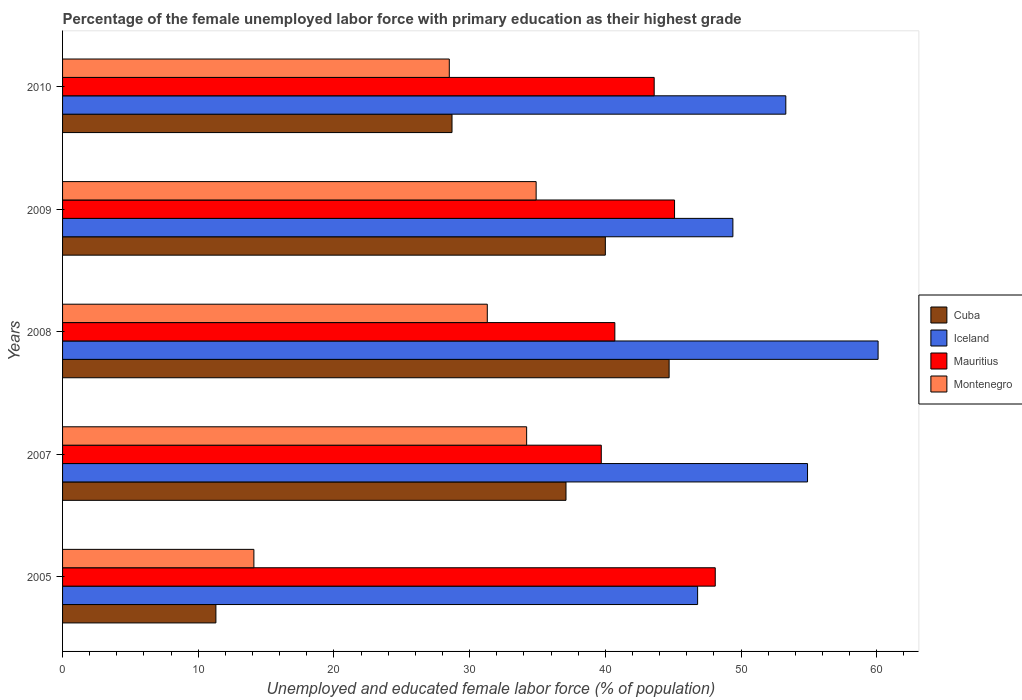How many different coloured bars are there?
Keep it short and to the point. 4. In how many cases, is the number of bars for a given year not equal to the number of legend labels?
Your answer should be compact. 0. What is the percentage of the unemployed female labor force with primary education in Cuba in 2007?
Offer a terse response. 37.1. Across all years, what is the maximum percentage of the unemployed female labor force with primary education in Iceland?
Offer a terse response. 60.1. Across all years, what is the minimum percentage of the unemployed female labor force with primary education in Montenegro?
Keep it short and to the point. 14.1. What is the total percentage of the unemployed female labor force with primary education in Iceland in the graph?
Provide a short and direct response. 264.5. What is the difference between the percentage of the unemployed female labor force with primary education in Cuba in 2008 and that in 2009?
Offer a very short reply. 4.7. What is the difference between the percentage of the unemployed female labor force with primary education in Iceland in 2008 and the percentage of the unemployed female labor force with primary education in Montenegro in 2007?
Give a very brief answer. 25.9. What is the average percentage of the unemployed female labor force with primary education in Montenegro per year?
Ensure brevity in your answer.  28.6. In the year 2010, what is the difference between the percentage of the unemployed female labor force with primary education in Montenegro and percentage of the unemployed female labor force with primary education in Cuba?
Provide a succinct answer. -0.2. In how many years, is the percentage of the unemployed female labor force with primary education in Cuba greater than 34 %?
Offer a terse response. 3. What is the ratio of the percentage of the unemployed female labor force with primary education in Iceland in 2008 to that in 2010?
Give a very brief answer. 1.13. Is the percentage of the unemployed female labor force with primary education in Montenegro in 2007 less than that in 2009?
Make the answer very short. Yes. What is the difference between the highest and the lowest percentage of the unemployed female labor force with primary education in Mauritius?
Give a very brief answer. 8.4. What does the 3rd bar from the bottom in 2009 represents?
Your answer should be compact. Mauritius. Are all the bars in the graph horizontal?
Give a very brief answer. Yes. How many years are there in the graph?
Offer a terse response. 5. What is the difference between two consecutive major ticks on the X-axis?
Make the answer very short. 10. Are the values on the major ticks of X-axis written in scientific E-notation?
Give a very brief answer. No. How many legend labels are there?
Your answer should be compact. 4. What is the title of the graph?
Your answer should be compact. Percentage of the female unemployed labor force with primary education as their highest grade. What is the label or title of the X-axis?
Your response must be concise. Unemployed and educated female labor force (% of population). What is the Unemployed and educated female labor force (% of population) of Cuba in 2005?
Your response must be concise. 11.3. What is the Unemployed and educated female labor force (% of population) in Iceland in 2005?
Provide a succinct answer. 46.8. What is the Unemployed and educated female labor force (% of population) in Mauritius in 2005?
Keep it short and to the point. 48.1. What is the Unemployed and educated female labor force (% of population) in Montenegro in 2005?
Make the answer very short. 14.1. What is the Unemployed and educated female labor force (% of population) in Cuba in 2007?
Make the answer very short. 37.1. What is the Unemployed and educated female labor force (% of population) in Iceland in 2007?
Offer a terse response. 54.9. What is the Unemployed and educated female labor force (% of population) in Mauritius in 2007?
Your response must be concise. 39.7. What is the Unemployed and educated female labor force (% of population) in Montenegro in 2007?
Provide a succinct answer. 34.2. What is the Unemployed and educated female labor force (% of population) in Cuba in 2008?
Provide a succinct answer. 44.7. What is the Unemployed and educated female labor force (% of population) of Iceland in 2008?
Your answer should be very brief. 60.1. What is the Unemployed and educated female labor force (% of population) of Mauritius in 2008?
Offer a very short reply. 40.7. What is the Unemployed and educated female labor force (% of population) in Montenegro in 2008?
Offer a terse response. 31.3. What is the Unemployed and educated female labor force (% of population) of Iceland in 2009?
Offer a very short reply. 49.4. What is the Unemployed and educated female labor force (% of population) of Mauritius in 2009?
Offer a terse response. 45.1. What is the Unemployed and educated female labor force (% of population) of Montenegro in 2009?
Offer a very short reply. 34.9. What is the Unemployed and educated female labor force (% of population) in Cuba in 2010?
Your answer should be very brief. 28.7. What is the Unemployed and educated female labor force (% of population) of Iceland in 2010?
Your answer should be compact. 53.3. What is the Unemployed and educated female labor force (% of population) in Mauritius in 2010?
Provide a short and direct response. 43.6. Across all years, what is the maximum Unemployed and educated female labor force (% of population) in Cuba?
Your answer should be very brief. 44.7. Across all years, what is the maximum Unemployed and educated female labor force (% of population) of Iceland?
Provide a short and direct response. 60.1. Across all years, what is the maximum Unemployed and educated female labor force (% of population) of Mauritius?
Make the answer very short. 48.1. Across all years, what is the maximum Unemployed and educated female labor force (% of population) in Montenegro?
Provide a succinct answer. 34.9. Across all years, what is the minimum Unemployed and educated female labor force (% of population) of Cuba?
Provide a short and direct response. 11.3. Across all years, what is the minimum Unemployed and educated female labor force (% of population) in Iceland?
Keep it short and to the point. 46.8. Across all years, what is the minimum Unemployed and educated female labor force (% of population) in Mauritius?
Offer a very short reply. 39.7. Across all years, what is the minimum Unemployed and educated female labor force (% of population) in Montenegro?
Offer a very short reply. 14.1. What is the total Unemployed and educated female labor force (% of population) of Cuba in the graph?
Your answer should be very brief. 161.8. What is the total Unemployed and educated female labor force (% of population) in Iceland in the graph?
Your answer should be compact. 264.5. What is the total Unemployed and educated female labor force (% of population) of Mauritius in the graph?
Make the answer very short. 217.2. What is the total Unemployed and educated female labor force (% of population) in Montenegro in the graph?
Your response must be concise. 143. What is the difference between the Unemployed and educated female labor force (% of population) of Cuba in 2005 and that in 2007?
Your answer should be compact. -25.8. What is the difference between the Unemployed and educated female labor force (% of population) of Iceland in 2005 and that in 2007?
Make the answer very short. -8.1. What is the difference between the Unemployed and educated female labor force (% of population) of Mauritius in 2005 and that in 2007?
Your answer should be compact. 8.4. What is the difference between the Unemployed and educated female labor force (% of population) of Montenegro in 2005 and that in 2007?
Your answer should be compact. -20.1. What is the difference between the Unemployed and educated female labor force (% of population) in Cuba in 2005 and that in 2008?
Make the answer very short. -33.4. What is the difference between the Unemployed and educated female labor force (% of population) in Montenegro in 2005 and that in 2008?
Ensure brevity in your answer.  -17.2. What is the difference between the Unemployed and educated female labor force (% of population) of Cuba in 2005 and that in 2009?
Offer a very short reply. -28.7. What is the difference between the Unemployed and educated female labor force (% of population) in Mauritius in 2005 and that in 2009?
Offer a very short reply. 3. What is the difference between the Unemployed and educated female labor force (% of population) of Montenegro in 2005 and that in 2009?
Offer a very short reply. -20.8. What is the difference between the Unemployed and educated female labor force (% of population) of Cuba in 2005 and that in 2010?
Provide a succinct answer. -17.4. What is the difference between the Unemployed and educated female labor force (% of population) in Iceland in 2005 and that in 2010?
Provide a short and direct response. -6.5. What is the difference between the Unemployed and educated female labor force (% of population) in Mauritius in 2005 and that in 2010?
Keep it short and to the point. 4.5. What is the difference between the Unemployed and educated female labor force (% of population) of Montenegro in 2005 and that in 2010?
Your answer should be compact. -14.4. What is the difference between the Unemployed and educated female labor force (% of population) in Iceland in 2007 and that in 2008?
Your answer should be compact. -5.2. What is the difference between the Unemployed and educated female labor force (% of population) in Mauritius in 2007 and that in 2008?
Your answer should be compact. -1. What is the difference between the Unemployed and educated female labor force (% of population) of Montenegro in 2007 and that in 2008?
Make the answer very short. 2.9. What is the difference between the Unemployed and educated female labor force (% of population) in Iceland in 2007 and that in 2009?
Your response must be concise. 5.5. What is the difference between the Unemployed and educated female labor force (% of population) of Mauritius in 2007 and that in 2009?
Provide a short and direct response. -5.4. What is the difference between the Unemployed and educated female labor force (% of population) in Cuba in 2007 and that in 2010?
Your answer should be compact. 8.4. What is the difference between the Unemployed and educated female labor force (% of population) of Mauritius in 2007 and that in 2010?
Give a very brief answer. -3.9. What is the difference between the Unemployed and educated female labor force (% of population) of Montenegro in 2007 and that in 2010?
Keep it short and to the point. 5.7. What is the difference between the Unemployed and educated female labor force (% of population) in Cuba in 2008 and that in 2009?
Make the answer very short. 4.7. What is the difference between the Unemployed and educated female labor force (% of population) of Iceland in 2008 and that in 2009?
Offer a terse response. 10.7. What is the difference between the Unemployed and educated female labor force (% of population) of Montenegro in 2008 and that in 2009?
Provide a short and direct response. -3.6. What is the difference between the Unemployed and educated female labor force (% of population) of Cuba in 2008 and that in 2010?
Your answer should be very brief. 16. What is the difference between the Unemployed and educated female labor force (% of population) of Iceland in 2008 and that in 2010?
Make the answer very short. 6.8. What is the difference between the Unemployed and educated female labor force (% of population) of Cuba in 2005 and the Unemployed and educated female labor force (% of population) of Iceland in 2007?
Ensure brevity in your answer.  -43.6. What is the difference between the Unemployed and educated female labor force (% of population) of Cuba in 2005 and the Unemployed and educated female labor force (% of population) of Mauritius in 2007?
Provide a succinct answer. -28.4. What is the difference between the Unemployed and educated female labor force (% of population) in Cuba in 2005 and the Unemployed and educated female labor force (% of population) in Montenegro in 2007?
Your answer should be very brief. -22.9. What is the difference between the Unemployed and educated female labor force (% of population) of Cuba in 2005 and the Unemployed and educated female labor force (% of population) of Iceland in 2008?
Give a very brief answer. -48.8. What is the difference between the Unemployed and educated female labor force (% of population) of Cuba in 2005 and the Unemployed and educated female labor force (% of population) of Mauritius in 2008?
Your response must be concise. -29.4. What is the difference between the Unemployed and educated female labor force (% of population) in Cuba in 2005 and the Unemployed and educated female labor force (% of population) in Montenegro in 2008?
Your response must be concise. -20. What is the difference between the Unemployed and educated female labor force (% of population) of Iceland in 2005 and the Unemployed and educated female labor force (% of population) of Montenegro in 2008?
Your answer should be very brief. 15.5. What is the difference between the Unemployed and educated female labor force (% of population) in Mauritius in 2005 and the Unemployed and educated female labor force (% of population) in Montenegro in 2008?
Offer a very short reply. 16.8. What is the difference between the Unemployed and educated female labor force (% of population) in Cuba in 2005 and the Unemployed and educated female labor force (% of population) in Iceland in 2009?
Keep it short and to the point. -38.1. What is the difference between the Unemployed and educated female labor force (% of population) of Cuba in 2005 and the Unemployed and educated female labor force (% of population) of Mauritius in 2009?
Your answer should be compact. -33.8. What is the difference between the Unemployed and educated female labor force (% of population) in Cuba in 2005 and the Unemployed and educated female labor force (% of population) in Montenegro in 2009?
Offer a terse response. -23.6. What is the difference between the Unemployed and educated female labor force (% of population) of Iceland in 2005 and the Unemployed and educated female labor force (% of population) of Mauritius in 2009?
Keep it short and to the point. 1.7. What is the difference between the Unemployed and educated female labor force (% of population) in Mauritius in 2005 and the Unemployed and educated female labor force (% of population) in Montenegro in 2009?
Ensure brevity in your answer.  13.2. What is the difference between the Unemployed and educated female labor force (% of population) of Cuba in 2005 and the Unemployed and educated female labor force (% of population) of Iceland in 2010?
Ensure brevity in your answer.  -42. What is the difference between the Unemployed and educated female labor force (% of population) of Cuba in 2005 and the Unemployed and educated female labor force (% of population) of Mauritius in 2010?
Provide a succinct answer. -32.3. What is the difference between the Unemployed and educated female labor force (% of population) of Cuba in 2005 and the Unemployed and educated female labor force (% of population) of Montenegro in 2010?
Offer a very short reply. -17.2. What is the difference between the Unemployed and educated female labor force (% of population) of Iceland in 2005 and the Unemployed and educated female labor force (% of population) of Mauritius in 2010?
Your answer should be compact. 3.2. What is the difference between the Unemployed and educated female labor force (% of population) in Mauritius in 2005 and the Unemployed and educated female labor force (% of population) in Montenegro in 2010?
Your answer should be compact. 19.6. What is the difference between the Unemployed and educated female labor force (% of population) of Cuba in 2007 and the Unemployed and educated female labor force (% of population) of Mauritius in 2008?
Offer a terse response. -3.6. What is the difference between the Unemployed and educated female labor force (% of population) of Iceland in 2007 and the Unemployed and educated female labor force (% of population) of Montenegro in 2008?
Offer a very short reply. 23.6. What is the difference between the Unemployed and educated female labor force (% of population) of Mauritius in 2007 and the Unemployed and educated female labor force (% of population) of Montenegro in 2008?
Provide a succinct answer. 8.4. What is the difference between the Unemployed and educated female labor force (% of population) of Cuba in 2007 and the Unemployed and educated female labor force (% of population) of Iceland in 2009?
Give a very brief answer. -12.3. What is the difference between the Unemployed and educated female labor force (% of population) in Cuba in 2007 and the Unemployed and educated female labor force (% of population) in Mauritius in 2009?
Ensure brevity in your answer.  -8. What is the difference between the Unemployed and educated female labor force (% of population) of Iceland in 2007 and the Unemployed and educated female labor force (% of population) of Mauritius in 2009?
Keep it short and to the point. 9.8. What is the difference between the Unemployed and educated female labor force (% of population) of Cuba in 2007 and the Unemployed and educated female labor force (% of population) of Iceland in 2010?
Give a very brief answer. -16.2. What is the difference between the Unemployed and educated female labor force (% of population) of Cuba in 2007 and the Unemployed and educated female labor force (% of population) of Mauritius in 2010?
Your answer should be compact. -6.5. What is the difference between the Unemployed and educated female labor force (% of population) in Cuba in 2007 and the Unemployed and educated female labor force (% of population) in Montenegro in 2010?
Your response must be concise. 8.6. What is the difference between the Unemployed and educated female labor force (% of population) of Iceland in 2007 and the Unemployed and educated female labor force (% of population) of Montenegro in 2010?
Provide a short and direct response. 26.4. What is the difference between the Unemployed and educated female labor force (% of population) in Iceland in 2008 and the Unemployed and educated female labor force (% of population) in Montenegro in 2009?
Your answer should be very brief. 25.2. What is the difference between the Unemployed and educated female labor force (% of population) of Mauritius in 2008 and the Unemployed and educated female labor force (% of population) of Montenegro in 2009?
Ensure brevity in your answer.  5.8. What is the difference between the Unemployed and educated female labor force (% of population) of Iceland in 2008 and the Unemployed and educated female labor force (% of population) of Montenegro in 2010?
Ensure brevity in your answer.  31.6. What is the difference between the Unemployed and educated female labor force (% of population) in Mauritius in 2008 and the Unemployed and educated female labor force (% of population) in Montenegro in 2010?
Provide a short and direct response. 12.2. What is the difference between the Unemployed and educated female labor force (% of population) of Cuba in 2009 and the Unemployed and educated female labor force (% of population) of Mauritius in 2010?
Keep it short and to the point. -3.6. What is the difference between the Unemployed and educated female labor force (% of population) of Cuba in 2009 and the Unemployed and educated female labor force (% of population) of Montenegro in 2010?
Offer a terse response. 11.5. What is the difference between the Unemployed and educated female labor force (% of population) of Iceland in 2009 and the Unemployed and educated female labor force (% of population) of Mauritius in 2010?
Ensure brevity in your answer.  5.8. What is the difference between the Unemployed and educated female labor force (% of population) in Iceland in 2009 and the Unemployed and educated female labor force (% of population) in Montenegro in 2010?
Offer a very short reply. 20.9. What is the average Unemployed and educated female labor force (% of population) of Cuba per year?
Give a very brief answer. 32.36. What is the average Unemployed and educated female labor force (% of population) of Iceland per year?
Provide a short and direct response. 52.9. What is the average Unemployed and educated female labor force (% of population) in Mauritius per year?
Make the answer very short. 43.44. What is the average Unemployed and educated female labor force (% of population) in Montenegro per year?
Your answer should be very brief. 28.6. In the year 2005, what is the difference between the Unemployed and educated female labor force (% of population) in Cuba and Unemployed and educated female labor force (% of population) in Iceland?
Provide a succinct answer. -35.5. In the year 2005, what is the difference between the Unemployed and educated female labor force (% of population) of Cuba and Unemployed and educated female labor force (% of population) of Mauritius?
Provide a short and direct response. -36.8. In the year 2005, what is the difference between the Unemployed and educated female labor force (% of population) in Iceland and Unemployed and educated female labor force (% of population) in Mauritius?
Give a very brief answer. -1.3. In the year 2005, what is the difference between the Unemployed and educated female labor force (% of population) of Iceland and Unemployed and educated female labor force (% of population) of Montenegro?
Give a very brief answer. 32.7. In the year 2007, what is the difference between the Unemployed and educated female labor force (% of population) of Cuba and Unemployed and educated female labor force (% of population) of Iceland?
Your response must be concise. -17.8. In the year 2007, what is the difference between the Unemployed and educated female labor force (% of population) of Iceland and Unemployed and educated female labor force (% of population) of Mauritius?
Keep it short and to the point. 15.2. In the year 2007, what is the difference between the Unemployed and educated female labor force (% of population) of Iceland and Unemployed and educated female labor force (% of population) of Montenegro?
Keep it short and to the point. 20.7. In the year 2008, what is the difference between the Unemployed and educated female labor force (% of population) of Cuba and Unemployed and educated female labor force (% of population) of Iceland?
Give a very brief answer. -15.4. In the year 2008, what is the difference between the Unemployed and educated female labor force (% of population) in Iceland and Unemployed and educated female labor force (% of population) in Mauritius?
Provide a succinct answer. 19.4. In the year 2008, what is the difference between the Unemployed and educated female labor force (% of population) of Iceland and Unemployed and educated female labor force (% of population) of Montenegro?
Ensure brevity in your answer.  28.8. In the year 2008, what is the difference between the Unemployed and educated female labor force (% of population) of Mauritius and Unemployed and educated female labor force (% of population) of Montenegro?
Offer a terse response. 9.4. In the year 2009, what is the difference between the Unemployed and educated female labor force (% of population) of Iceland and Unemployed and educated female labor force (% of population) of Mauritius?
Your answer should be compact. 4.3. In the year 2009, what is the difference between the Unemployed and educated female labor force (% of population) of Mauritius and Unemployed and educated female labor force (% of population) of Montenegro?
Your answer should be compact. 10.2. In the year 2010, what is the difference between the Unemployed and educated female labor force (% of population) in Cuba and Unemployed and educated female labor force (% of population) in Iceland?
Your answer should be compact. -24.6. In the year 2010, what is the difference between the Unemployed and educated female labor force (% of population) in Cuba and Unemployed and educated female labor force (% of population) in Mauritius?
Your answer should be very brief. -14.9. In the year 2010, what is the difference between the Unemployed and educated female labor force (% of population) of Iceland and Unemployed and educated female labor force (% of population) of Montenegro?
Offer a terse response. 24.8. In the year 2010, what is the difference between the Unemployed and educated female labor force (% of population) of Mauritius and Unemployed and educated female labor force (% of population) of Montenegro?
Make the answer very short. 15.1. What is the ratio of the Unemployed and educated female labor force (% of population) of Cuba in 2005 to that in 2007?
Ensure brevity in your answer.  0.3. What is the ratio of the Unemployed and educated female labor force (% of population) in Iceland in 2005 to that in 2007?
Offer a terse response. 0.85. What is the ratio of the Unemployed and educated female labor force (% of population) in Mauritius in 2005 to that in 2007?
Offer a very short reply. 1.21. What is the ratio of the Unemployed and educated female labor force (% of population) in Montenegro in 2005 to that in 2007?
Offer a terse response. 0.41. What is the ratio of the Unemployed and educated female labor force (% of population) of Cuba in 2005 to that in 2008?
Provide a short and direct response. 0.25. What is the ratio of the Unemployed and educated female labor force (% of population) of Iceland in 2005 to that in 2008?
Offer a very short reply. 0.78. What is the ratio of the Unemployed and educated female labor force (% of population) in Mauritius in 2005 to that in 2008?
Provide a succinct answer. 1.18. What is the ratio of the Unemployed and educated female labor force (% of population) of Montenegro in 2005 to that in 2008?
Your answer should be very brief. 0.45. What is the ratio of the Unemployed and educated female labor force (% of population) of Cuba in 2005 to that in 2009?
Offer a terse response. 0.28. What is the ratio of the Unemployed and educated female labor force (% of population) of Mauritius in 2005 to that in 2009?
Offer a very short reply. 1.07. What is the ratio of the Unemployed and educated female labor force (% of population) in Montenegro in 2005 to that in 2009?
Offer a terse response. 0.4. What is the ratio of the Unemployed and educated female labor force (% of population) in Cuba in 2005 to that in 2010?
Your response must be concise. 0.39. What is the ratio of the Unemployed and educated female labor force (% of population) of Iceland in 2005 to that in 2010?
Give a very brief answer. 0.88. What is the ratio of the Unemployed and educated female labor force (% of population) of Mauritius in 2005 to that in 2010?
Your answer should be compact. 1.1. What is the ratio of the Unemployed and educated female labor force (% of population) of Montenegro in 2005 to that in 2010?
Give a very brief answer. 0.49. What is the ratio of the Unemployed and educated female labor force (% of population) in Cuba in 2007 to that in 2008?
Provide a short and direct response. 0.83. What is the ratio of the Unemployed and educated female labor force (% of population) in Iceland in 2007 to that in 2008?
Provide a short and direct response. 0.91. What is the ratio of the Unemployed and educated female labor force (% of population) of Mauritius in 2007 to that in 2008?
Ensure brevity in your answer.  0.98. What is the ratio of the Unemployed and educated female labor force (% of population) of Montenegro in 2007 to that in 2008?
Offer a very short reply. 1.09. What is the ratio of the Unemployed and educated female labor force (% of population) of Cuba in 2007 to that in 2009?
Provide a short and direct response. 0.93. What is the ratio of the Unemployed and educated female labor force (% of population) in Iceland in 2007 to that in 2009?
Keep it short and to the point. 1.11. What is the ratio of the Unemployed and educated female labor force (% of population) in Mauritius in 2007 to that in 2009?
Your response must be concise. 0.88. What is the ratio of the Unemployed and educated female labor force (% of population) in Montenegro in 2007 to that in 2009?
Keep it short and to the point. 0.98. What is the ratio of the Unemployed and educated female labor force (% of population) of Cuba in 2007 to that in 2010?
Ensure brevity in your answer.  1.29. What is the ratio of the Unemployed and educated female labor force (% of population) in Mauritius in 2007 to that in 2010?
Your answer should be compact. 0.91. What is the ratio of the Unemployed and educated female labor force (% of population) of Montenegro in 2007 to that in 2010?
Provide a short and direct response. 1.2. What is the ratio of the Unemployed and educated female labor force (% of population) of Cuba in 2008 to that in 2009?
Make the answer very short. 1.12. What is the ratio of the Unemployed and educated female labor force (% of population) in Iceland in 2008 to that in 2009?
Your answer should be very brief. 1.22. What is the ratio of the Unemployed and educated female labor force (% of population) in Mauritius in 2008 to that in 2009?
Offer a very short reply. 0.9. What is the ratio of the Unemployed and educated female labor force (% of population) of Montenegro in 2008 to that in 2009?
Make the answer very short. 0.9. What is the ratio of the Unemployed and educated female labor force (% of population) in Cuba in 2008 to that in 2010?
Your answer should be very brief. 1.56. What is the ratio of the Unemployed and educated female labor force (% of population) in Iceland in 2008 to that in 2010?
Provide a short and direct response. 1.13. What is the ratio of the Unemployed and educated female labor force (% of population) in Mauritius in 2008 to that in 2010?
Your answer should be compact. 0.93. What is the ratio of the Unemployed and educated female labor force (% of population) in Montenegro in 2008 to that in 2010?
Your answer should be very brief. 1.1. What is the ratio of the Unemployed and educated female labor force (% of population) of Cuba in 2009 to that in 2010?
Ensure brevity in your answer.  1.39. What is the ratio of the Unemployed and educated female labor force (% of population) in Iceland in 2009 to that in 2010?
Provide a short and direct response. 0.93. What is the ratio of the Unemployed and educated female labor force (% of population) of Mauritius in 2009 to that in 2010?
Your response must be concise. 1.03. What is the ratio of the Unemployed and educated female labor force (% of population) in Montenegro in 2009 to that in 2010?
Offer a terse response. 1.22. What is the difference between the highest and the second highest Unemployed and educated female labor force (% of population) of Cuba?
Your answer should be very brief. 4.7. What is the difference between the highest and the second highest Unemployed and educated female labor force (% of population) in Iceland?
Keep it short and to the point. 5.2. What is the difference between the highest and the lowest Unemployed and educated female labor force (% of population) in Cuba?
Make the answer very short. 33.4. What is the difference between the highest and the lowest Unemployed and educated female labor force (% of population) in Montenegro?
Provide a short and direct response. 20.8. 